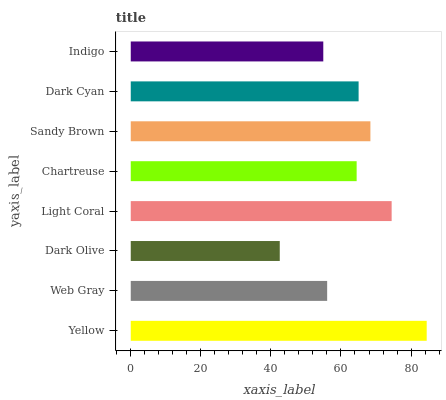Is Dark Olive the minimum?
Answer yes or no. Yes. Is Yellow the maximum?
Answer yes or no. Yes. Is Web Gray the minimum?
Answer yes or no. No. Is Web Gray the maximum?
Answer yes or no. No. Is Yellow greater than Web Gray?
Answer yes or no. Yes. Is Web Gray less than Yellow?
Answer yes or no. Yes. Is Web Gray greater than Yellow?
Answer yes or no. No. Is Yellow less than Web Gray?
Answer yes or no. No. Is Dark Cyan the high median?
Answer yes or no. Yes. Is Chartreuse the low median?
Answer yes or no. Yes. Is Dark Olive the high median?
Answer yes or no. No. Is Yellow the low median?
Answer yes or no. No. 